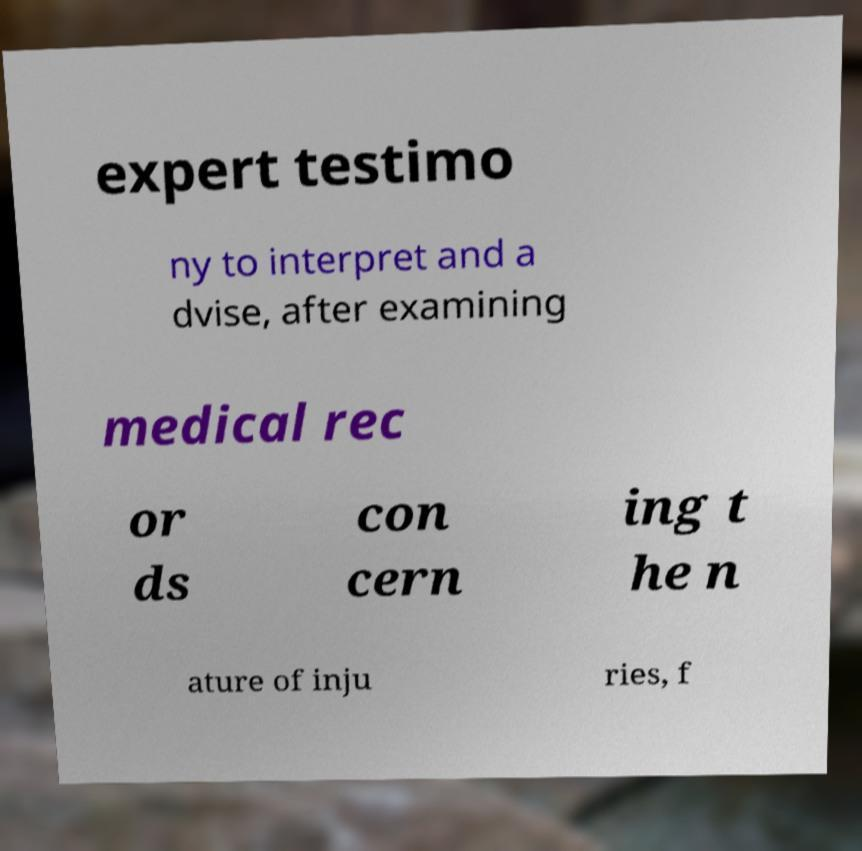There's text embedded in this image that I need extracted. Can you transcribe it verbatim? expert testimo ny to interpret and a dvise, after examining medical rec or ds con cern ing t he n ature of inju ries, f 